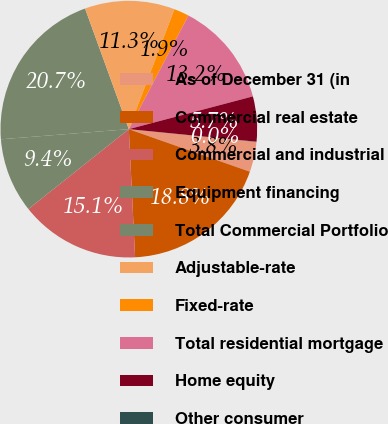Convert chart. <chart><loc_0><loc_0><loc_500><loc_500><pie_chart><fcel>As of December 31 (in<fcel>Commercial real estate<fcel>Commercial and industrial<fcel>Equipment financing<fcel>Total Commercial Portfolio<fcel>Adjustable-rate<fcel>Fixed-rate<fcel>Total residential mortgage<fcel>Home equity<fcel>Other consumer<nl><fcel>3.79%<fcel>18.84%<fcel>15.08%<fcel>9.44%<fcel>20.72%<fcel>11.32%<fcel>1.91%<fcel>13.2%<fcel>5.67%<fcel>0.03%<nl></chart> 